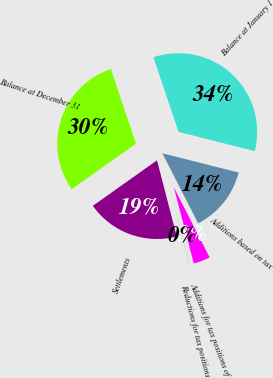<chart> <loc_0><loc_0><loc_500><loc_500><pie_chart><fcel>Balance at January 1<fcel>Additions based on tax<fcel>Additions for tax positions of<fcel>Reductions for tax positions<fcel>Settlements<fcel>Balance at December 31<nl><fcel>34.09%<fcel>13.54%<fcel>3.44%<fcel>0.04%<fcel>19.22%<fcel>29.67%<nl></chart> 